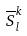<formula> <loc_0><loc_0><loc_500><loc_500>\overline { S } _ { l } ^ { k }</formula> 